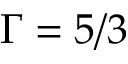<formula> <loc_0><loc_0><loc_500><loc_500>\Gamma = 5 / 3</formula> 